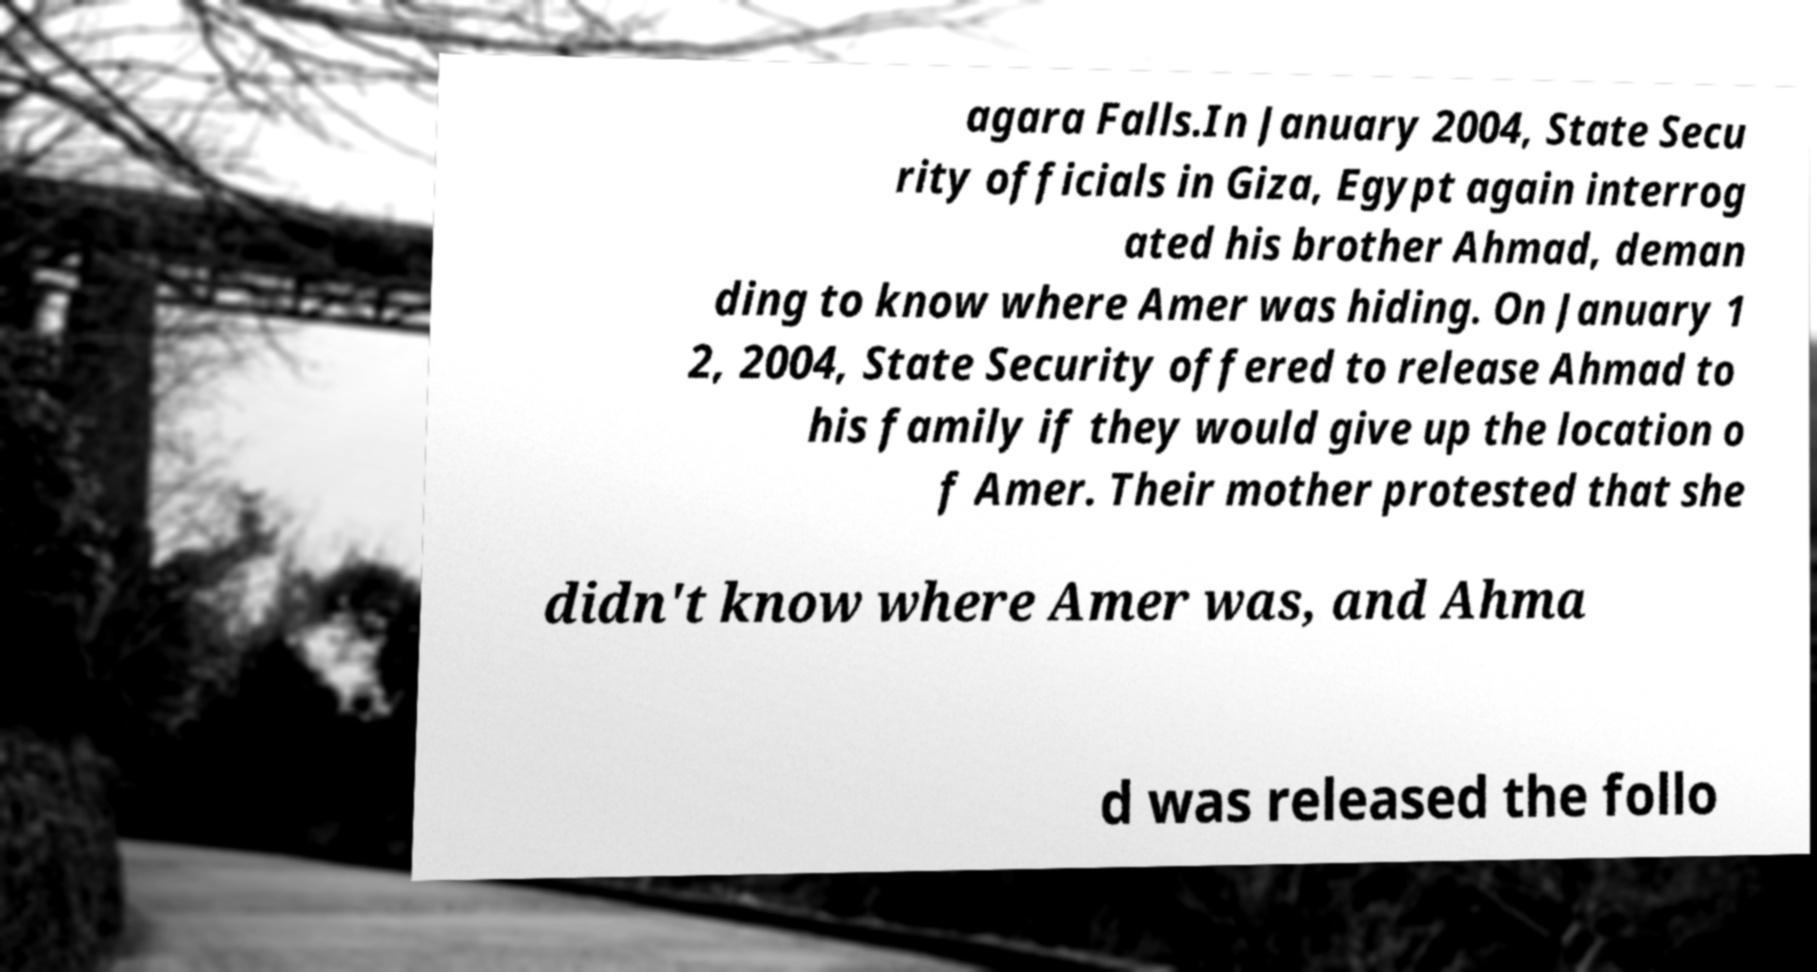I need the written content from this picture converted into text. Can you do that? agara Falls.In January 2004, State Secu rity officials in Giza, Egypt again interrog ated his brother Ahmad, deman ding to know where Amer was hiding. On January 1 2, 2004, State Security offered to release Ahmad to his family if they would give up the location o f Amer. Their mother protested that she didn't know where Amer was, and Ahma d was released the follo 